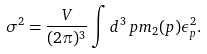Convert formula to latex. <formula><loc_0><loc_0><loc_500><loc_500>\sigma ^ { 2 } = \frac { V } { ( 2 \pi ) ^ { 3 } } \int d ^ { 3 } \, p m _ { 2 } ( p ) \epsilon _ { p } ^ { 2 } .</formula> 